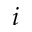<formula> <loc_0><loc_0><loc_500><loc_500>i</formula> 